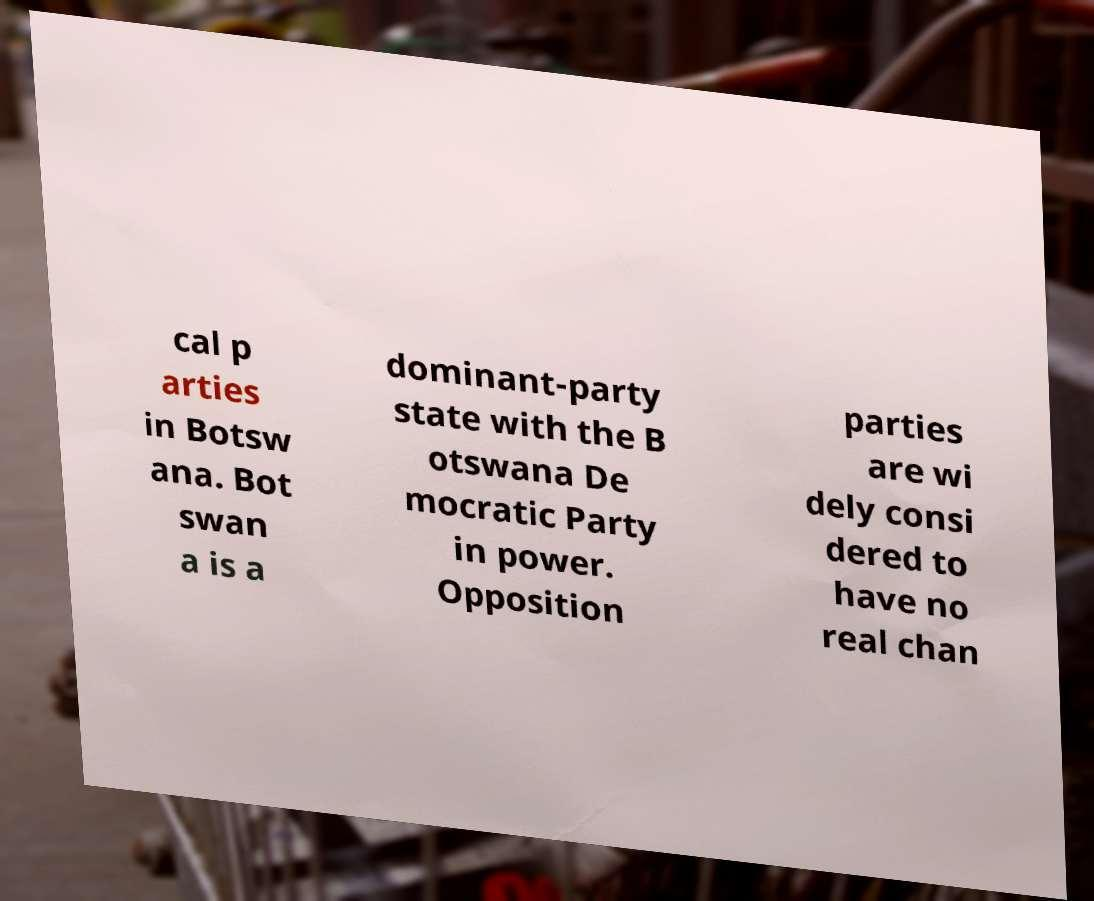Could you extract and type out the text from this image? cal p arties in Botsw ana. Bot swan a is a dominant-party state with the B otswana De mocratic Party in power. Opposition parties are wi dely consi dered to have no real chan 